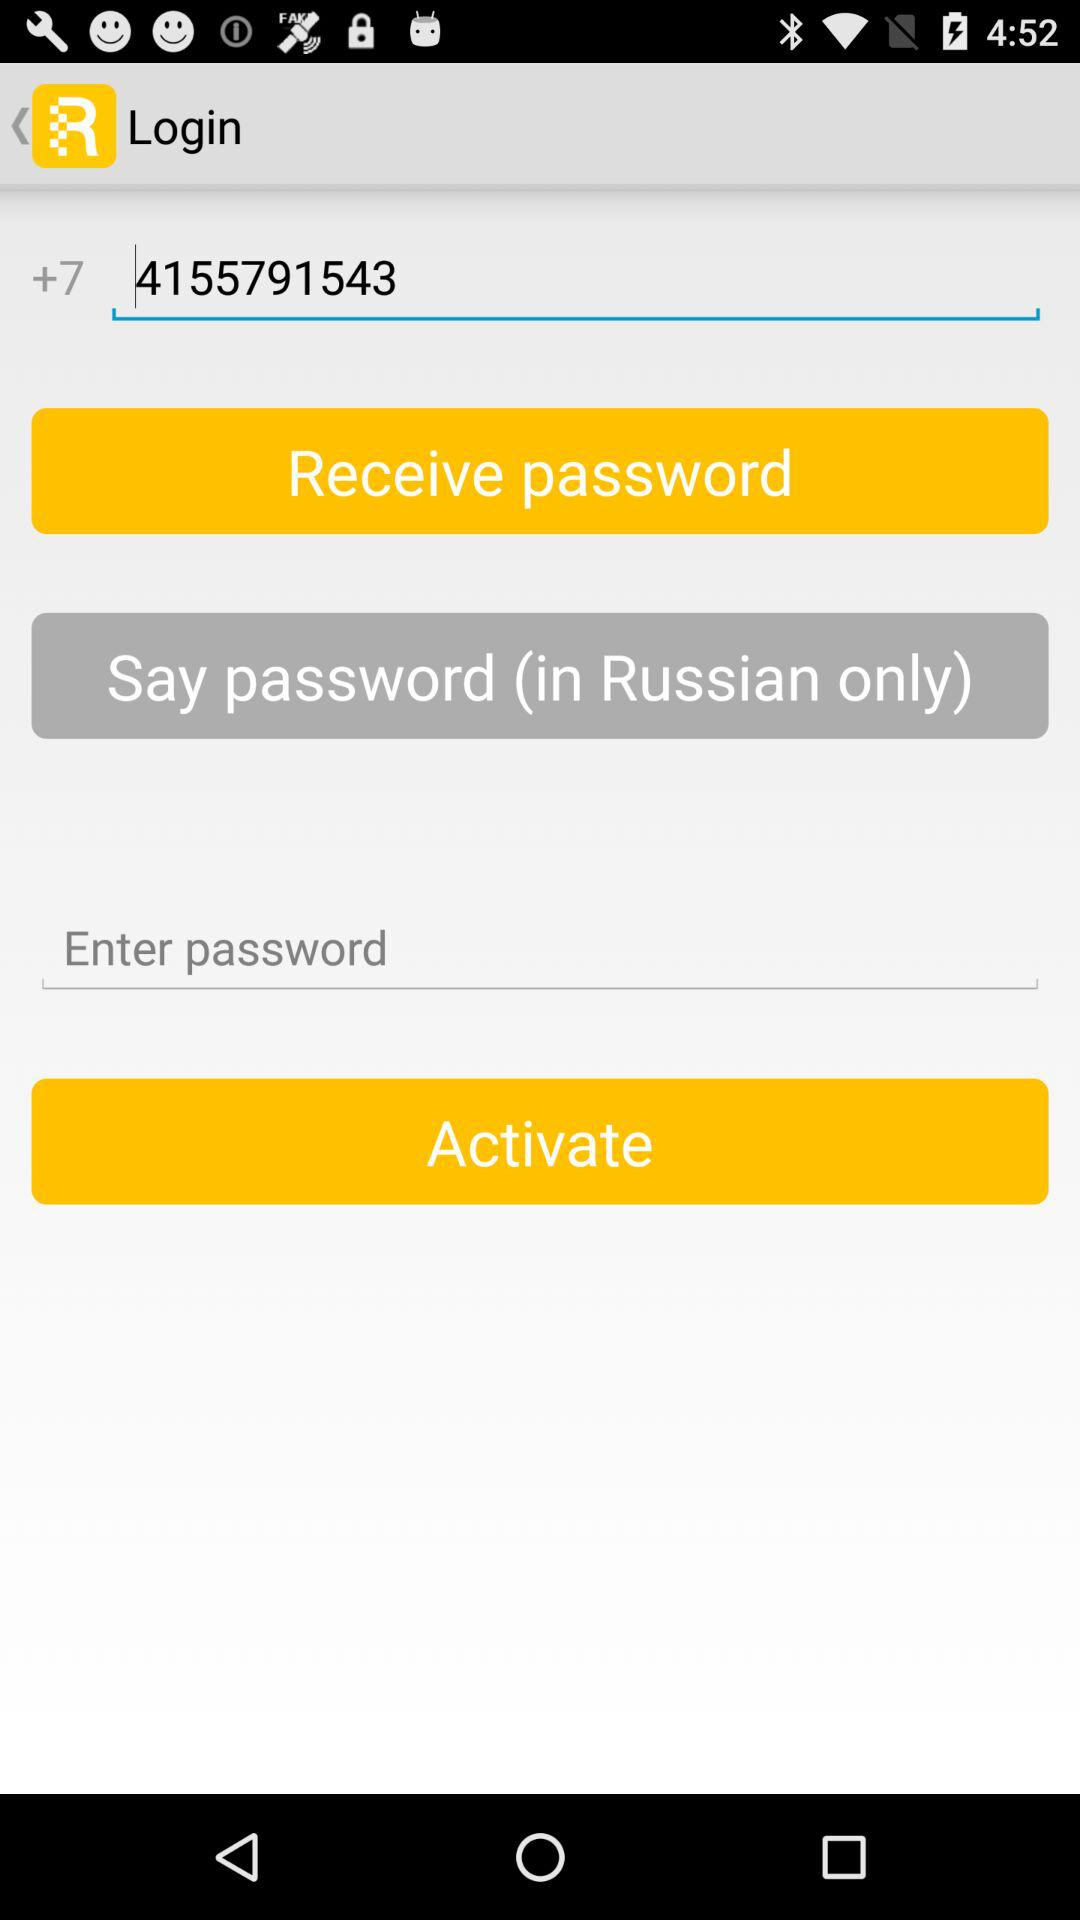Which language is selected for the password? The selected language is Russian. 